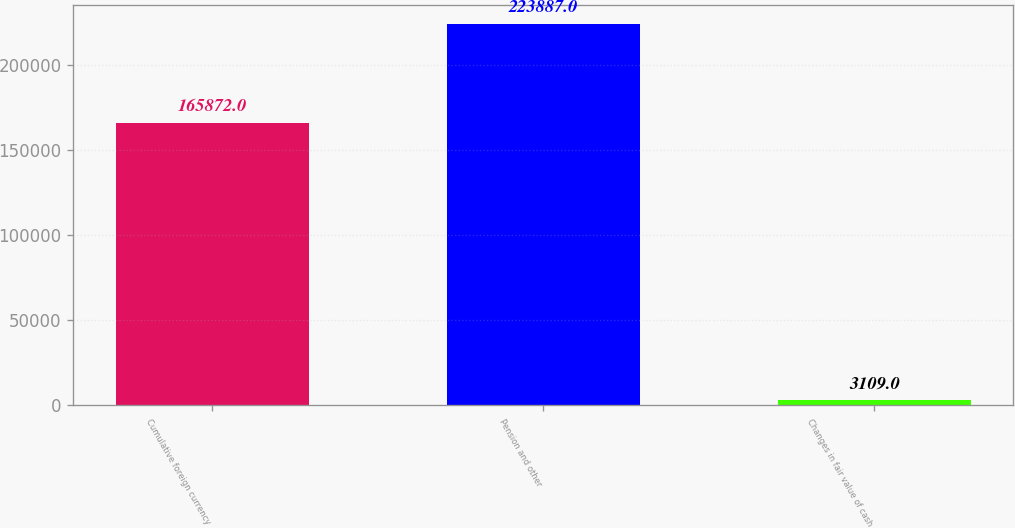Convert chart. <chart><loc_0><loc_0><loc_500><loc_500><bar_chart><fcel>Cumulative foreign currency<fcel>Pension and other<fcel>Changes in fair value of cash<nl><fcel>165872<fcel>223887<fcel>3109<nl></chart> 